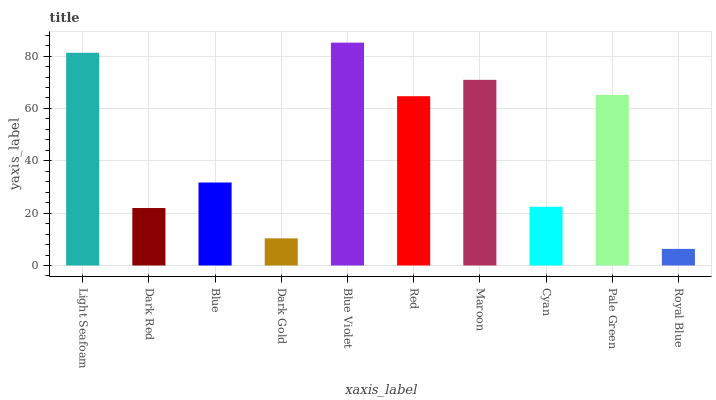Is Royal Blue the minimum?
Answer yes or no. Yes. Is Blue Violet the maximum?
Answer yes or no. Yes. Is Dark Red the minimum?
Answer yes or no. No. Is Dark Red the maximum?
Answer yes or no. No. Is Light Seafoam greater than Dark Red?
Answer yes or no. Yes. Is Dark Red less than Light Seafoam?
Answer yes or no. Yes. Is Dark Red greater than Light Seafoam?
Answer yes or no. No. Is Light Seafoam less than Dark Red?
Answer yes or no. No. Is Red the high median?
Answer yes or no. Yes. Is Blue the low median?
Answer yes or no. Yes. Is Light Seafoam the high median?
Answer yes or no. No. Is Red the low median?
Answer yes or no. No. 